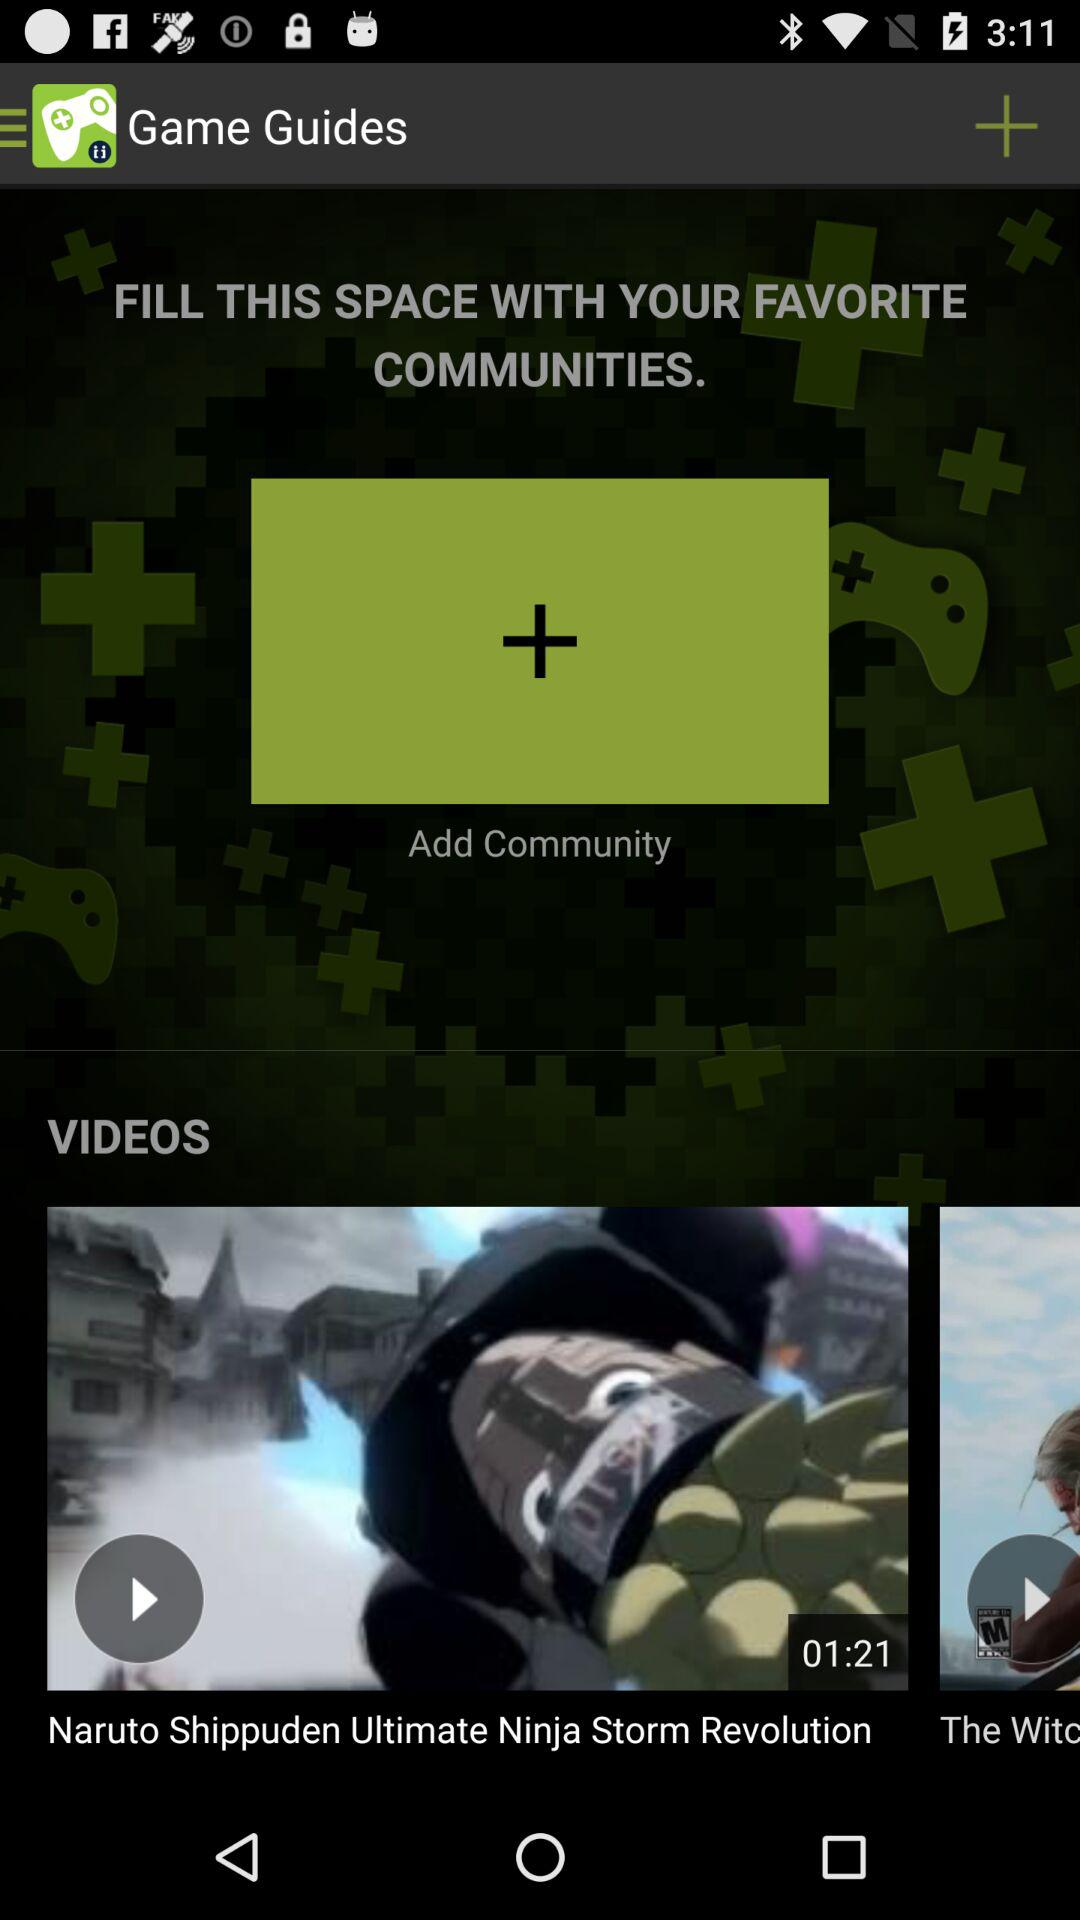What is the name of the application? The name of the application is "Game Guides". 